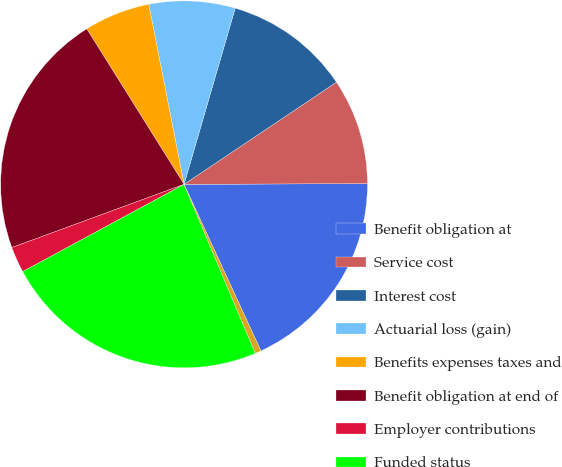Convert chart. <chart><loc_0><loc_0><loc_500><loc_500><pie_chart><fcel>Benefit obligation at<fcel>Service cost<fcel>Interest cost<fcel>Actuarial loss (gain)<fcel>Benefits expenses taxes and<fcel>Benefit obligation at end of<fcel>Employer contributions<fcel>Funded status<fcel>Other accrued liabilities<nl><fcel>18.18%<fcel>9.34%<fcel>11.1%<fcel>7.58%<fcel>5.82%<fcel>21.7%<fcel>2.29%<fcel>23.46%<fcel>0.53%<nl></chart> 